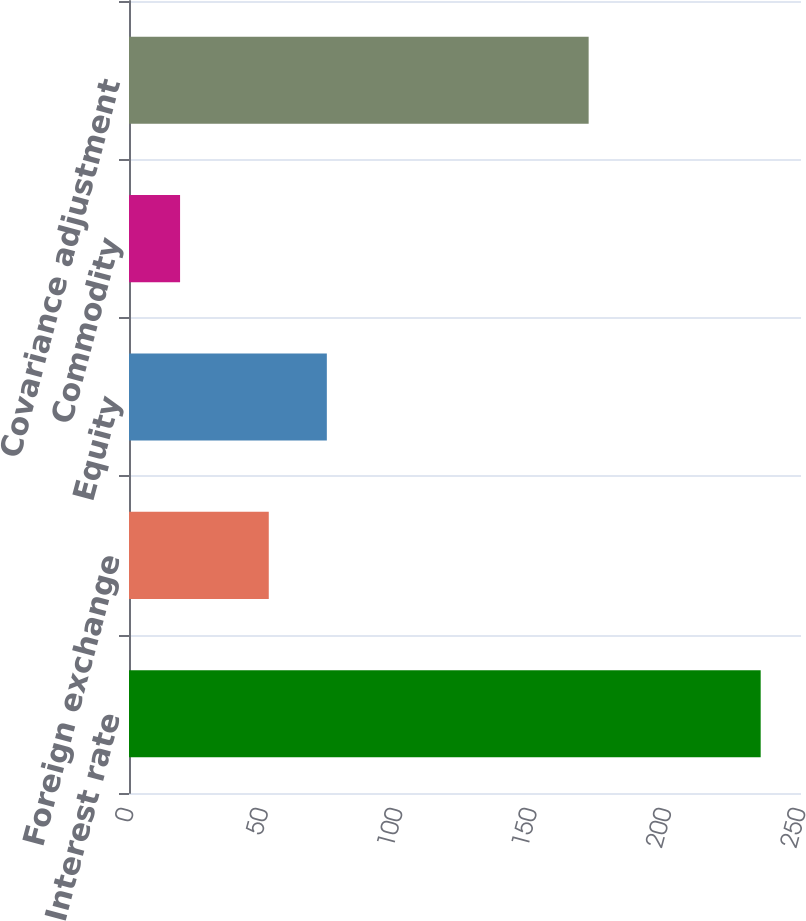Convert chart to OTSL. <chart><loc_0><loc_0><loc_500><loc_500><bar_chart><fcel>Interest rate<fcel>Foreign exchange<fcel>Equity<fcel>Commodity<fcel>Covariance adjustment<nl><fcel>235<fcel>52<fcel>73.6<fcel>19<fcel>171<nl></chart> 